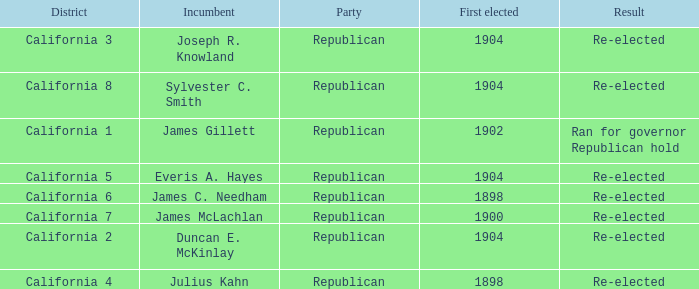Which Incumbent has a District of California 5? Everis A. Hayes. 